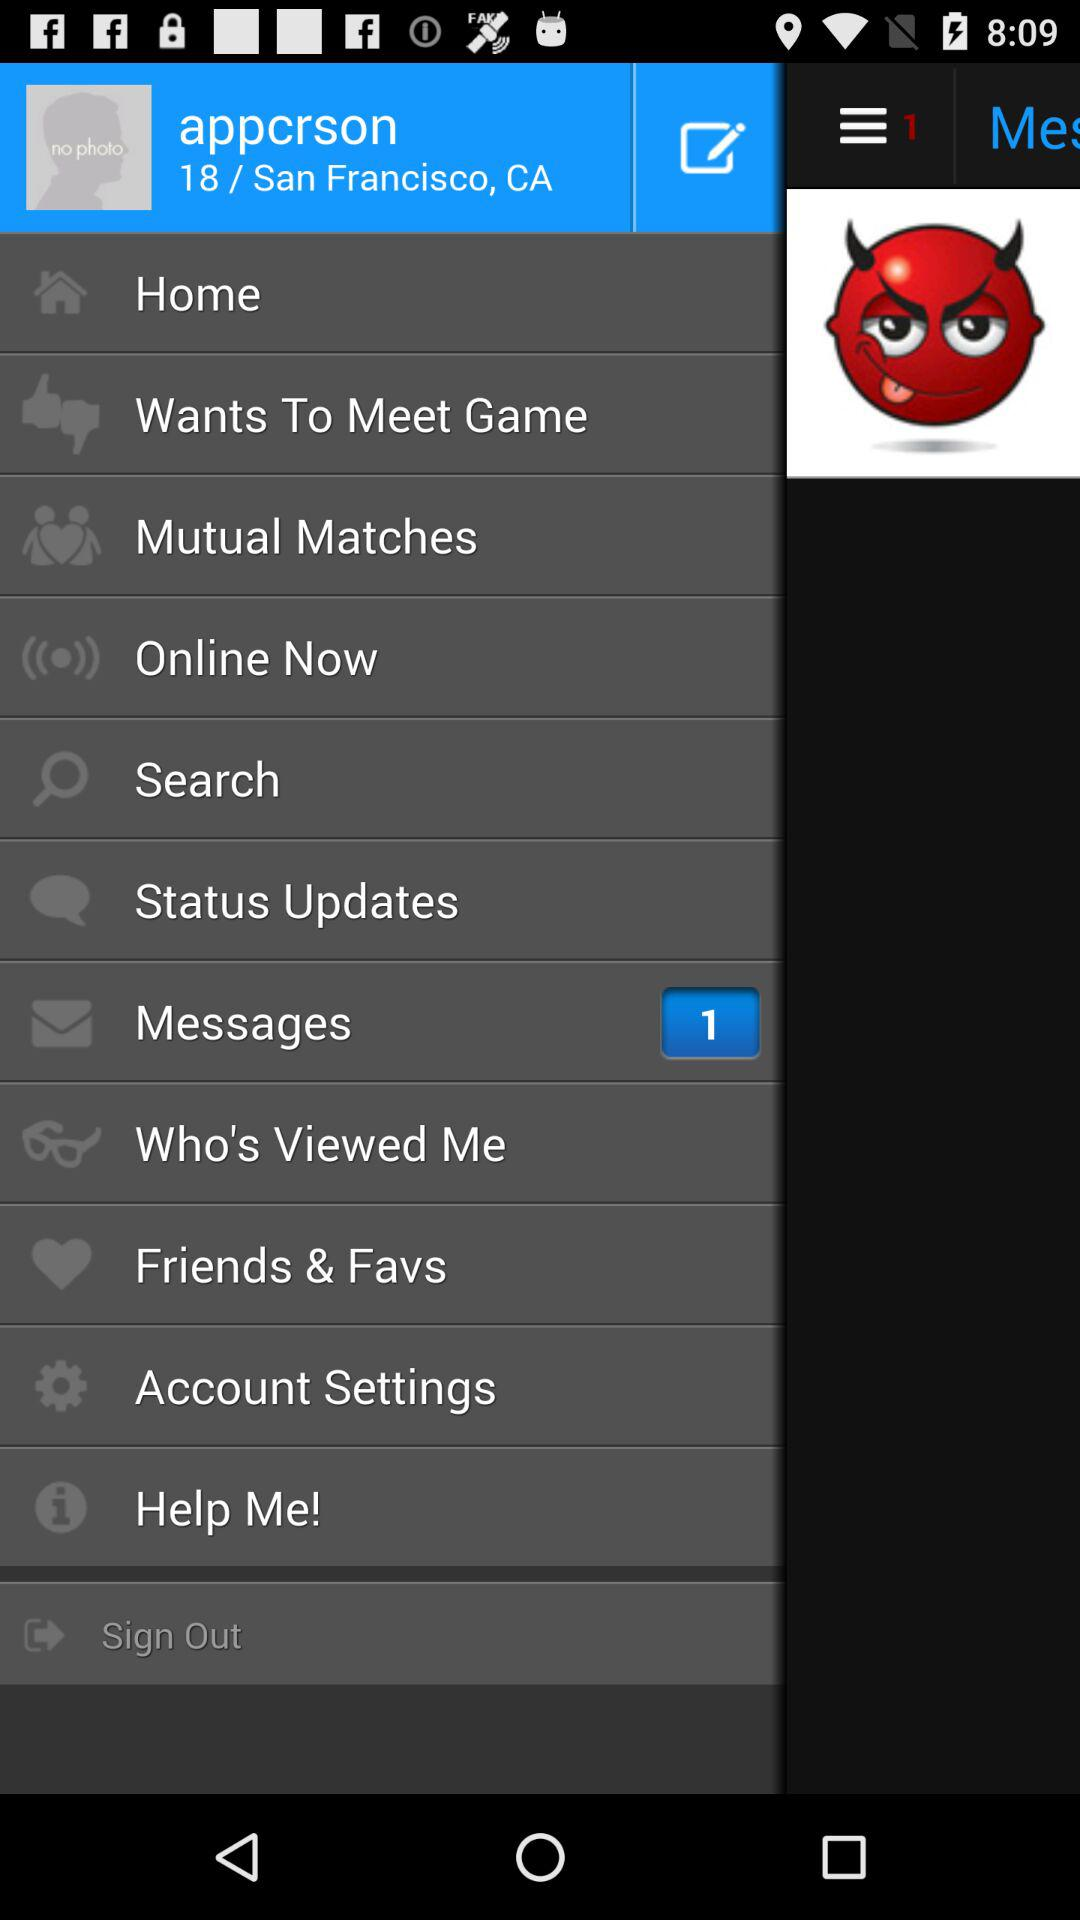What is the number of new messages? The number of new messages is 1. 